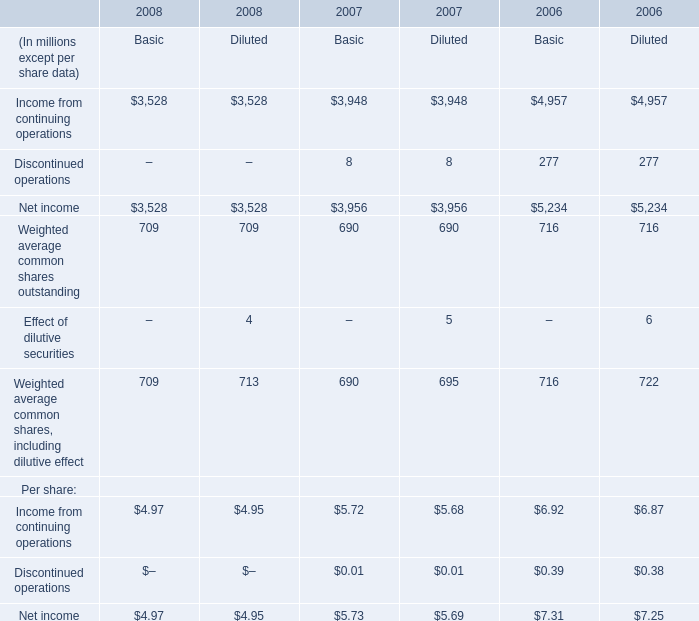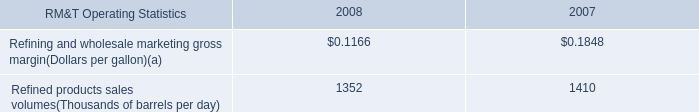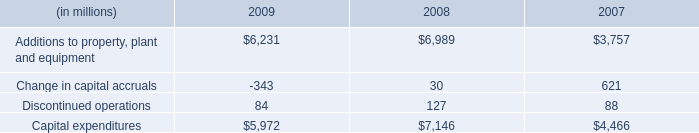What's the average of Additions to property, plant and equipment of 2008, and Income from continuing operations of 2008 Diluted ? 
Computations: ((6989.0 + 3528.0) / 2)
Answer: 5258.5. In the year with largest amount of Additions to property, plant and equipment what's the sum of Income from continuing operations ? 
Computations: (3528 + 3528)
Answer: 7056.0. 